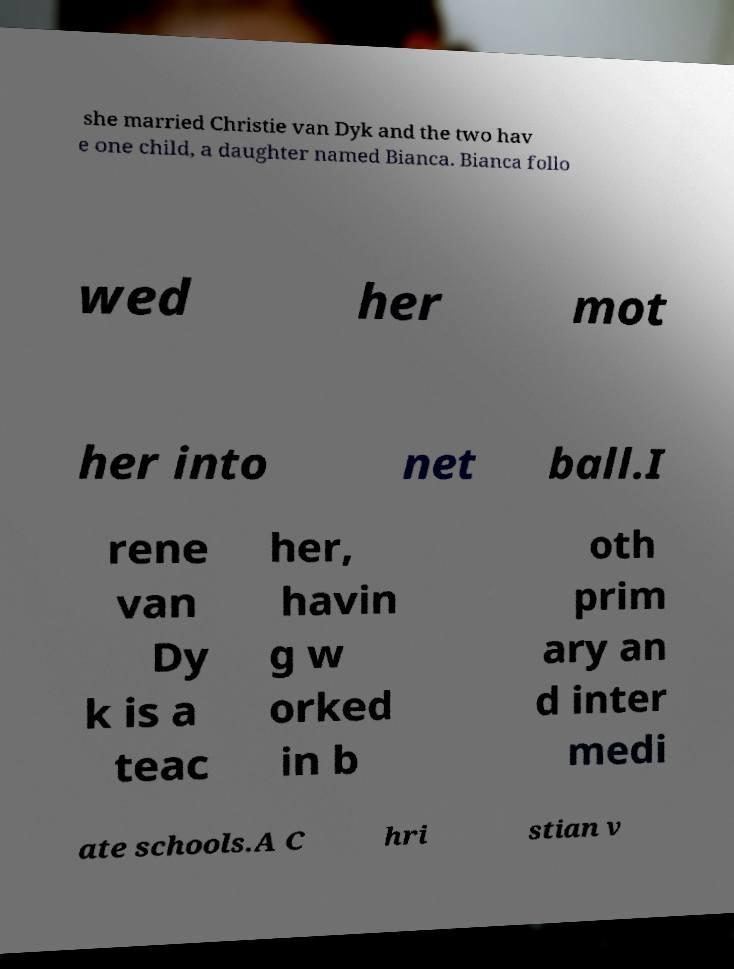Can you read and provide the text displayed in the image?This photo seems to have some interesting text. Can you extract and type it out for me? she married Christie van Dyk and the two hav e one child, a daughter named Bianca. Bianca follo wed her mot her into net ball.I rene van Dy k is a teac her, havin g w orked in b oth prim ary an d inter medi ate schools.A C hri stian v 